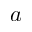<formula> <loc_0><loc_0><loc_500><loc_500>a</formula> 